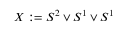<formula> <loc_0><loc_0><loc_500><loc_500>X \colon = S ^ { 2 } \vee S ^ { 1 } \vee S ^ { 1 }</formula> 